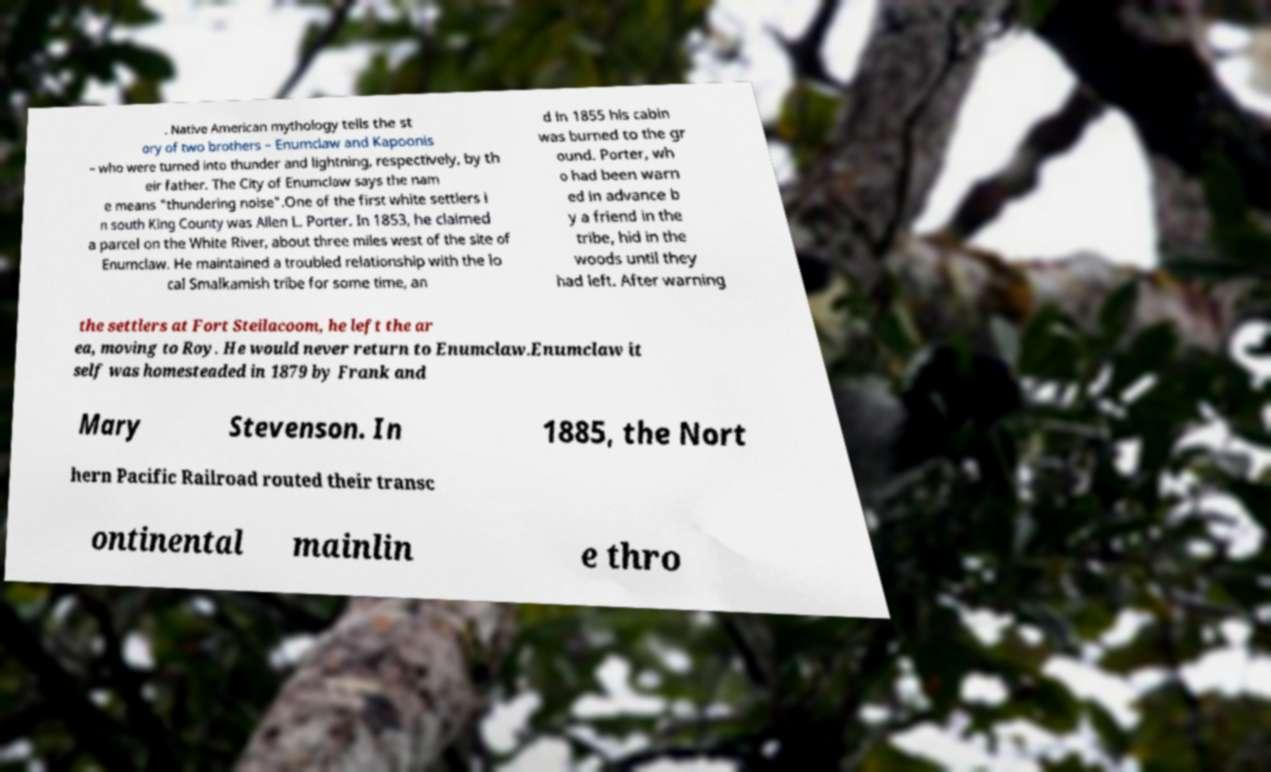Can you read and provide the text displayed in the image?This photo seems to have some interesting text. Can you extract and type it out for me? . Native American mythology tells the st ory of two brothers – Enumclaw and Kapoonis – who were turned into thunder and lightning, respectively, by th eir father. The City of Enumclaw says the nam e means "thundering noise".One of the first white settlers i n south King County was Allen L. Porter. In 1853, he claimed a parcel on the White River, about three miles west of the site of Enumclaw. He maintained a troubled relationship with the lo cal Smalkamish tribe for some time, an d in 1855 his cabin was burned to the gr ound. Porter, wh o had been warn ed in advance b y a friend in the tribe, hid in the woods until they had left. After warning the settlers at Fort Steilacoom, he left the ar ea, moving to Roy. He would never return to Enumclaw.Enumclaw it self was homesteaded in 1879 by Frank and Mary Stevenson. In 1885, the Nort hern Pacific Railroad routed their transc ontinental mainlin e thro 